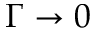Convert formula to latex. <formula><loc_0><loc_0><loc_500><loc_500>\Gamma \rightarrow 0</formula> 